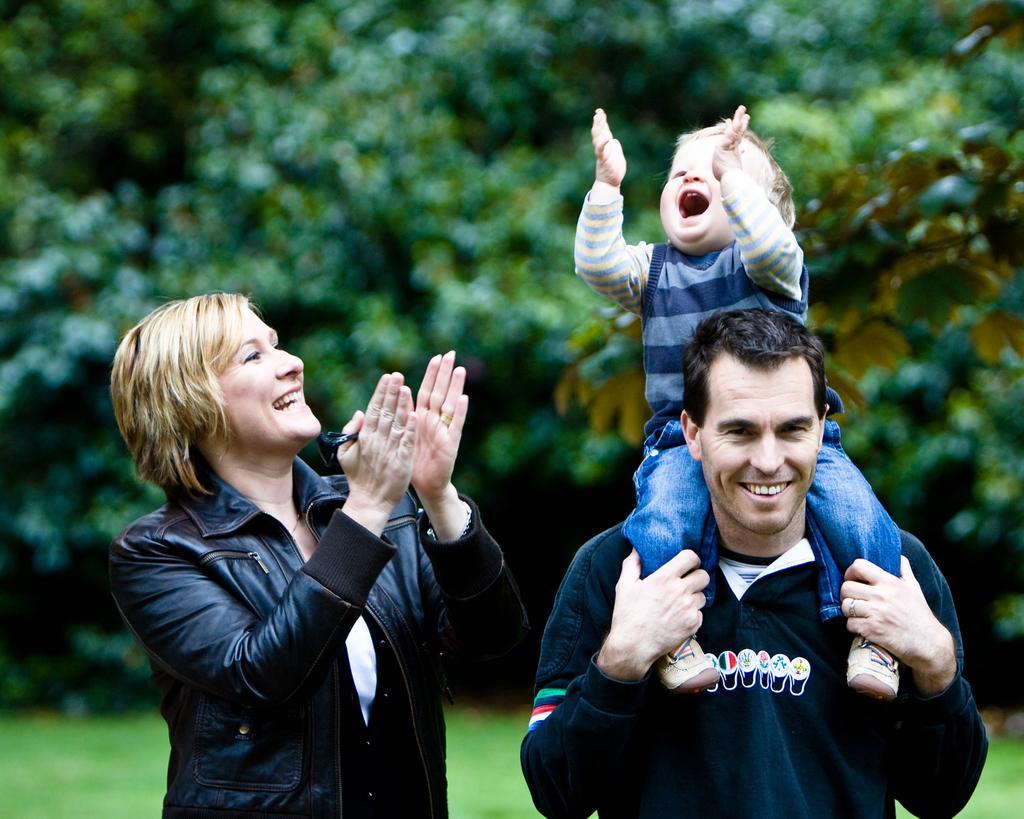Can you describe this image briefly? In this image we can see a woman wearing black jacket and this person wearing T-shirt is carrying a child and they all are smiling. The background of the image is blurred, where we can see the grass and trees. 